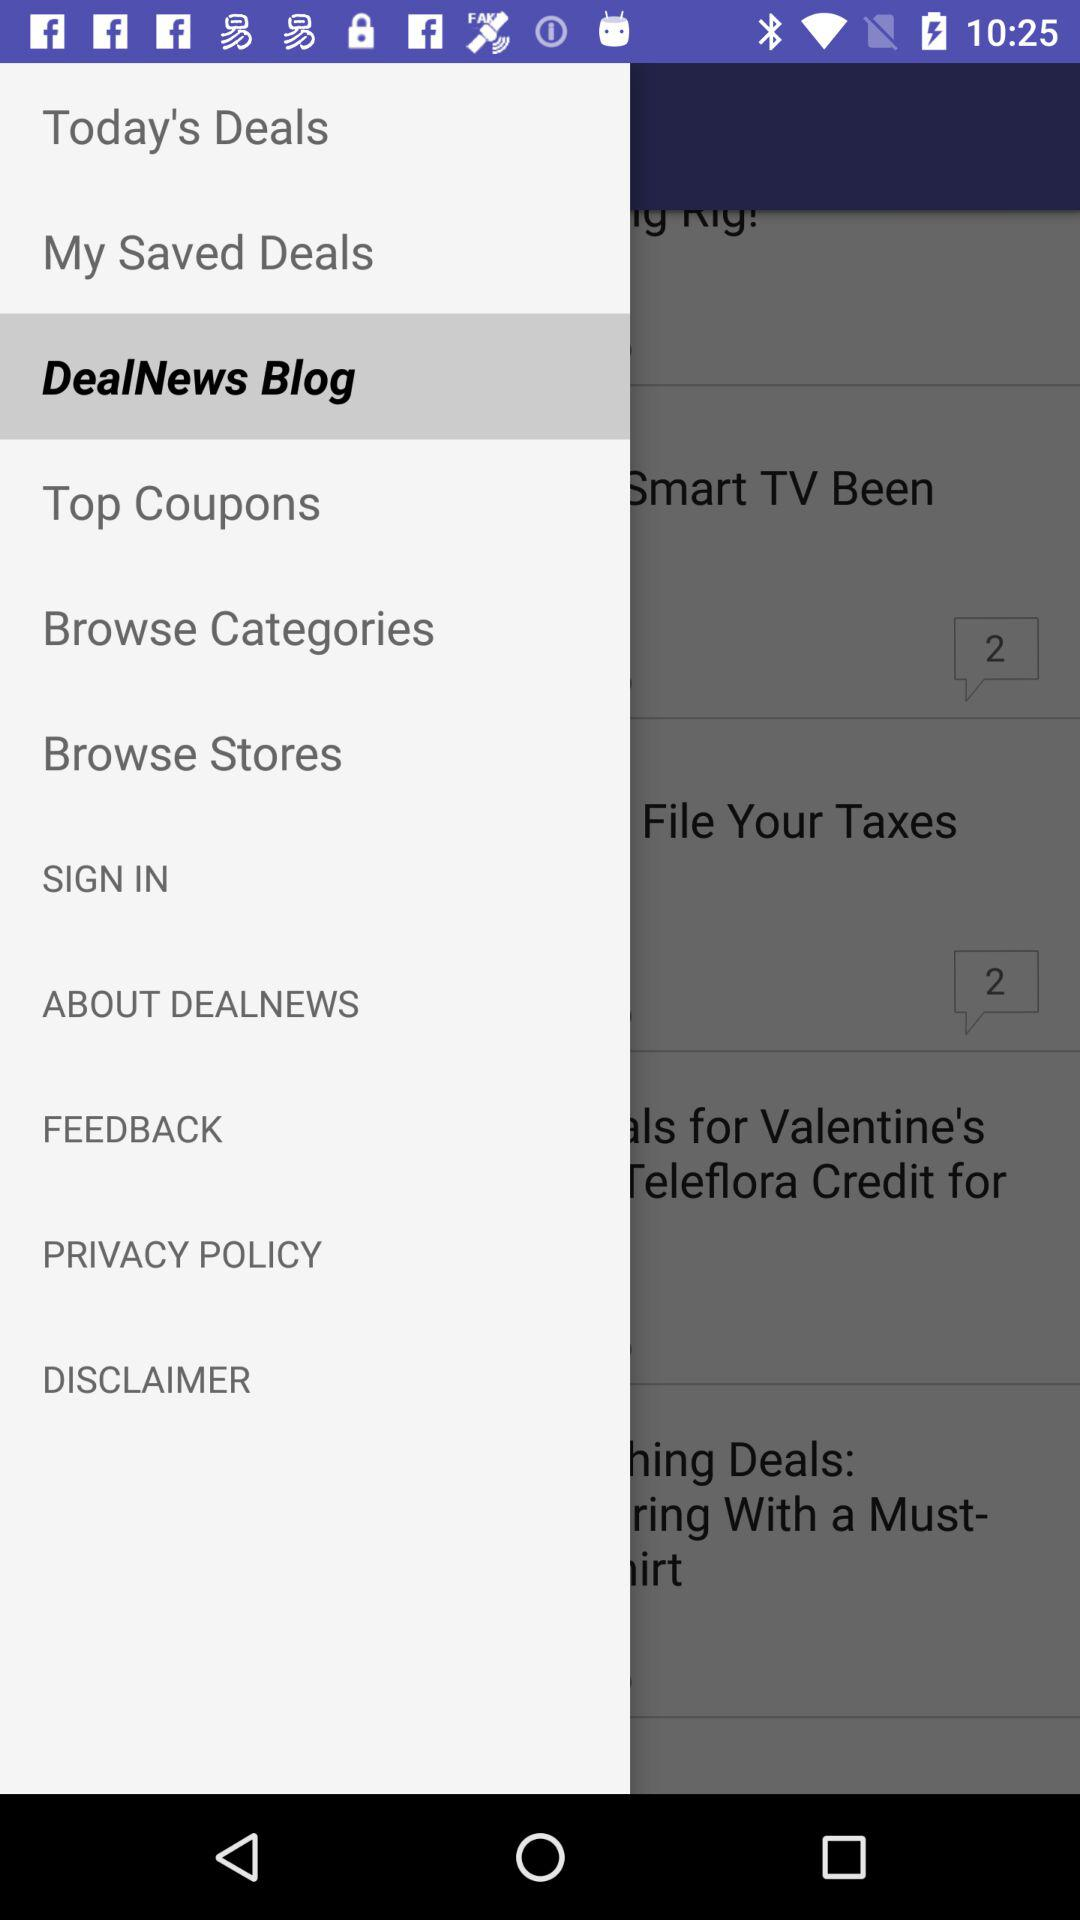What's the selected option? The selected option is "DealNews Blog". 